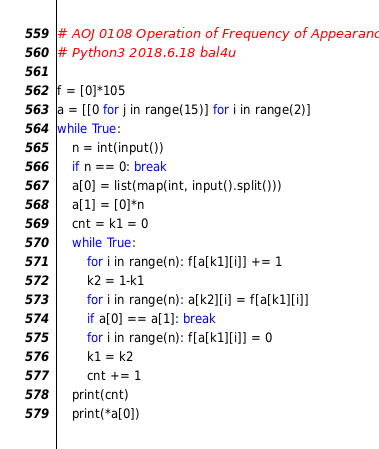Convert code to text. <code><loc_0><loc_0><loc_500><loc_500><_Python_># AOJ 0108 Operation of Frequency of Appearance
# Python3 2018.6.18 bal4u

f = [0]*105
a = [[0 for j in range(15)] for i in range(2)]
while True:
	n = int(input())
	if n == 0: break
	a[0] = list(map(int, input().split()))
	a[1] = [0]*n
	cnt = k1 = 0
	while True:
		for i in range(n): f[a[k1][i]] += 1
		k2 = 1-k1
		for i in range(n): a[k2][i] = f[a[k1][i]]
		if a[0] == a[1]: break
		for i in range(n): f[a[k1][i]] = 0
		k1 = k2
		cnt += 1
	print(cnt)
	print(*a[0])
</code> 